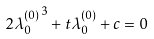<formula> <loc_0><loc_0><loc_500><loc_500>2 { \lambda ^ { ( 0 ) } _ { 0 } } ^ { 3 } + t \lambda ^ { ( 0 ) } _ { 0 } + c = 0</formula> 